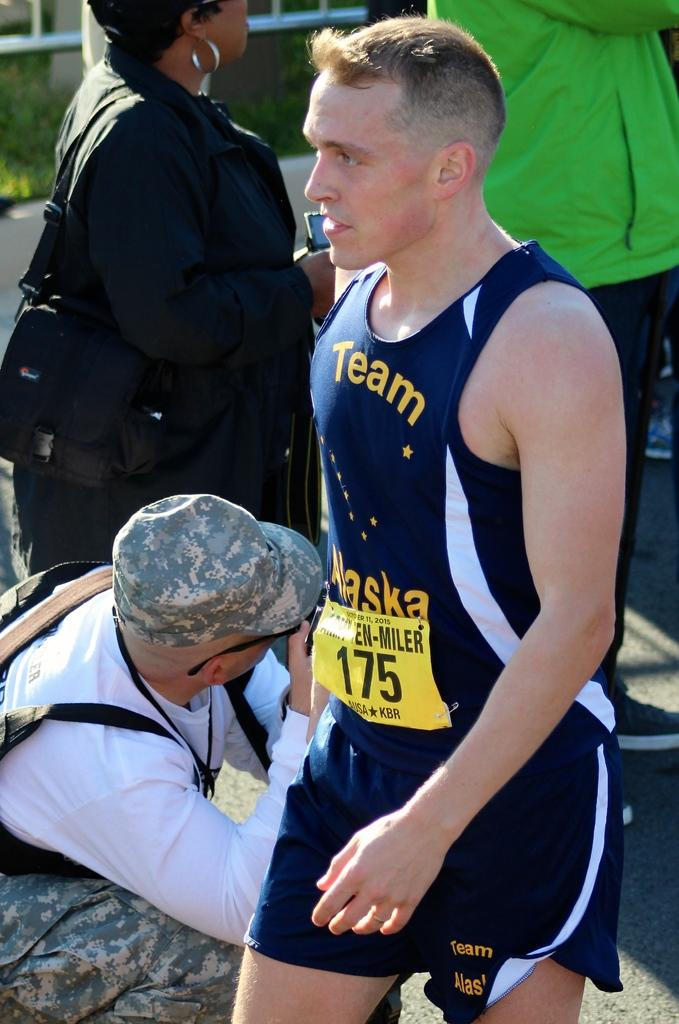Provide a one-sentence caption for the provided image. A man wearing a running outfit that has the numerals 175 on the front. 